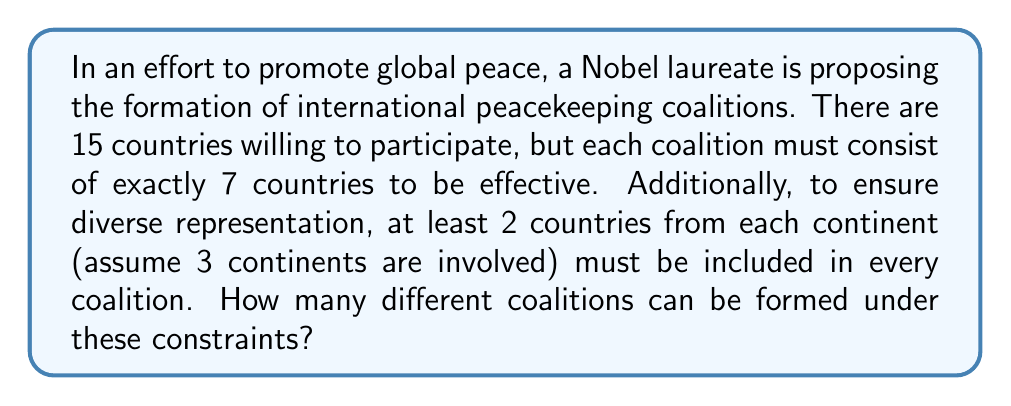Solve this math problem. Let's approach this step-by-step using the principle of inclusion-exclusion:

1) First, let's distribute the countries among the continents:
   Continent 1: 5 countries
   Continent 2: 5 countries
   Continent 3: 5 countries

2) We need to select at least 2 countries from each continent. Let's consider the complement of this - the number of ways to select 7 countries with at least one continent having fewer than 2 countries.

3) Let $A_i$ be the set of selections where continent $i$ has fewer than 2 countries. We need to find $|A_1 \cup A_2 \cup A_3|$ and subtract it from the total number of ways to select 7 countries from 15.

4) By the principle of inclusion-exclusion:

   $$|A_1 \cup A_2 \cup A_3| = |A_1| + |A_2| + |A_3| - |A_1 \cap A_2| - |A_1 \cap A_3| - |A_2 \cap A_3| + |A_1 \cap A_2 \cap A_3|$$

5) Calculate each term:
   - $|A_i| = \binom{5}{0}\binom{10}{7} + \binom{5}{1}\binom{10}{6} = 120 + 1500 = 1620$
   - $|A_i \cap A_j| = \binom{5}{0}\binom{5}{0}\binom{5}{7} + \binom{5}{0}\binom{5}{1}\binom{5}{6} + \binom{5}{1}\binom{5}{0}\binom{5}{6} = 0 + 0 + 0 = 0$
   - $|A_1 \cap A_2 \cap A_3| = 0$ (impossible to select 7 countries with fewer than 2 from each continent)

6) Therefore:
   $$|A_1 \cup A_2 \cup A_3| = 1620 + 1620 + 1620 - 0 - 0 - 0 + 0 = 4860$$

7) The total number of ways to select 7 countries from 15 is $\binom{15}{7} = 6435$

8) Thus, the number of valid coalitions is:
   $$6435 - 4860 = 1575$$
Answer: 1575 